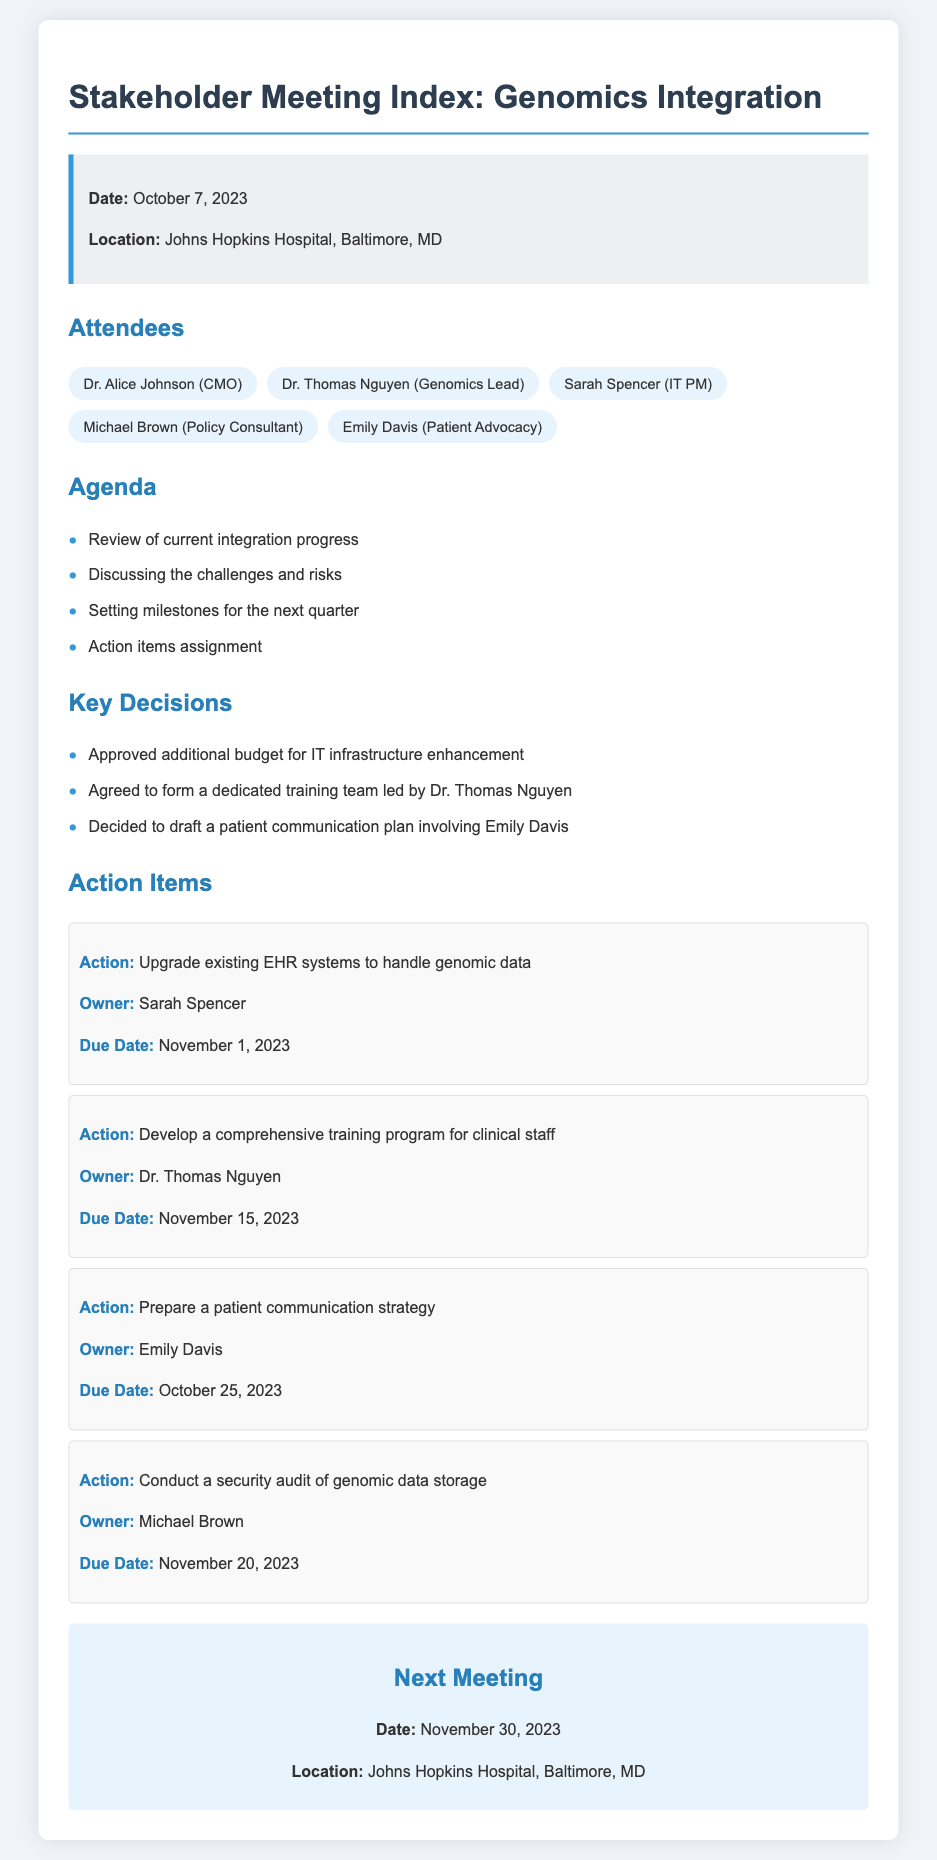What is the date of the meeting? The date of the meeting is specified in the meeting information section of the document.
Answer: October 7, 2023 Who is the Genomics Lead? The name of the Genomics Lead is listed among the attendees.
Answer: Dr. Thomas Nguyen What is the location of the next meeting? The location of the next meeting is indicated in the next meeting section of the document.
Answer: Johns Hopkins Hospital, Baltimore, MD What is the due date for the patient communication strategy? The due date for the patient communication strategy is mentioned in the action items section.
Answer: October 25, 2023 What key decision was made regarding the training team? The decision about the training team is recorded in the key decisions section.
Answer: Form a dedicated training team led by Dr. Thomas Nguyen What action item is assigned to Michael Brown? The action assigned to Michael Brown is detailed in the action items section.
Answer: Conduct a security audit of genomic data storage How many attendees are listed in the document? The total number of attendees is calculated by counting the names provided in the attendees section.
Answer: 5 What is listed as one of the agenda items? One of the agenda items can be found in the agenda list.
Answer: Discussing the challenges and risks 